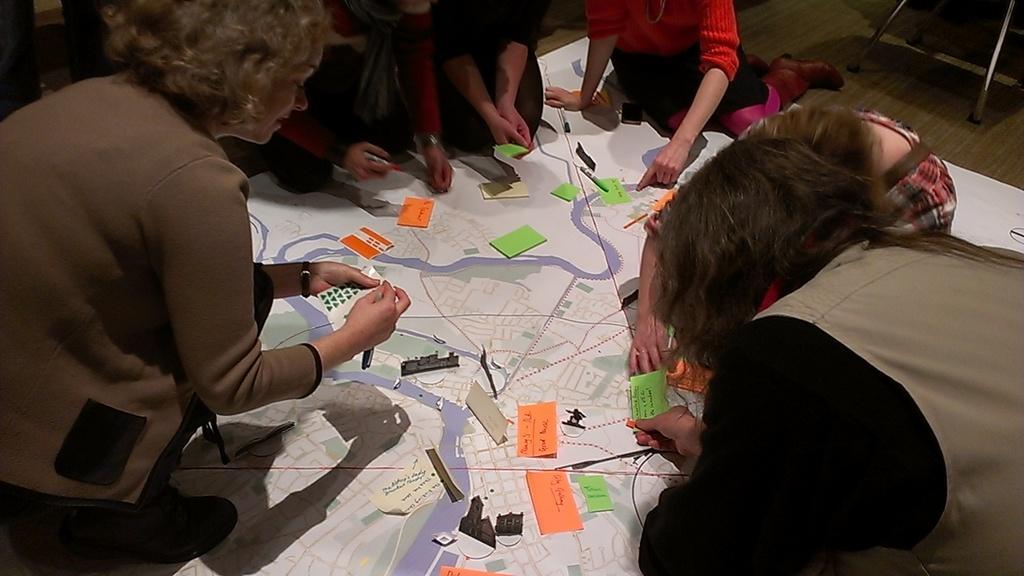Describe this image in one or two sentences. The woman in the right bottom of the picture is holding a green color paper in her hands. In this picture, we see people are trying to paste the stickers and papers on the white color board. In the background, we see an iron stand. At the bottom of the picture, we see papers in white, orange and green color are placed on the board. 